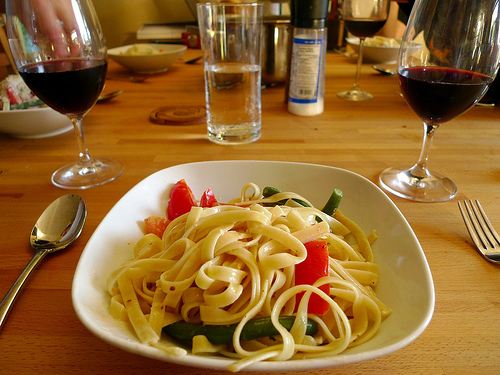<image>
Can you confirm if the pasta is next to the bowl? No. The pasta is not positioned next to the bowl. They are located in different areas of the scene. Is there a food under the table? No. The food is not positioned under the table. The vertical relationship between these objects is different. Is the fork in the glass? No. The fork is not contained within the glass. These objects have a different spatial relationship. Is there a glass above the table? No. The glass is not positioned above the table. The vertical arrangement shows a different relationship. 